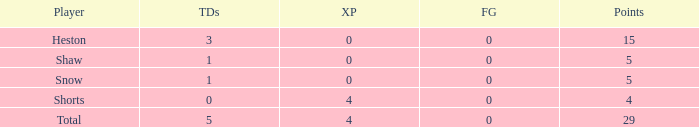What is the total number of field goals for a player that had less than 3 touchdowns, had 4 points, and had less than 4 extra points? 0.0. 